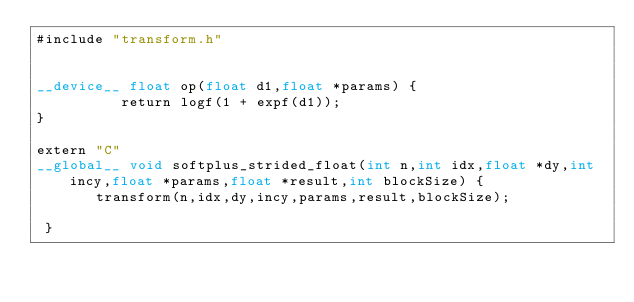<code> <loc_0><loc_0><loc_500><loc_500><_Cuda_>#include "transform.h"


__device__ float op(float d1,float *params) {
          return logf(1 + expf(d1));
}

extern "C"
__global__ void softplus_strided_float(int n,int idx,float *dy,int incy,float *params,float *result,int blockSize) {
       transform(n,idx,dy,incy,params,result,blockSize);

 }</code> 